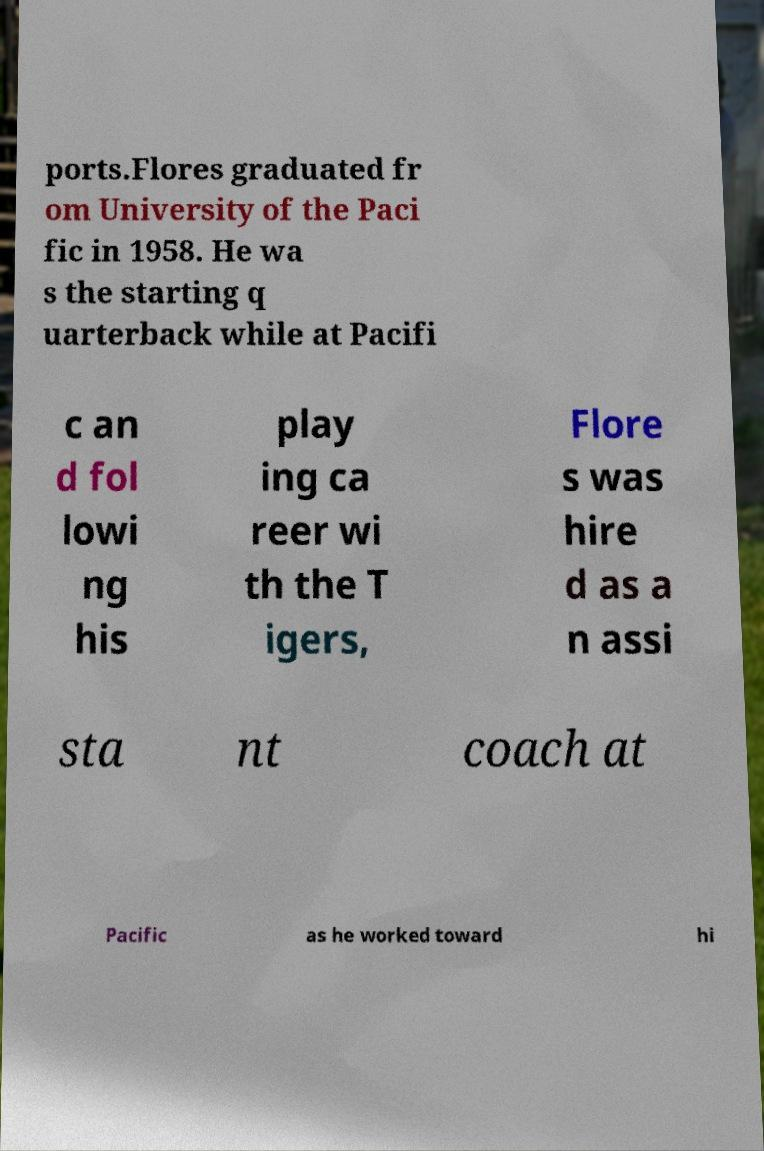Can you accurately transcribe the text from the provided image for me? ports.Flores graduated fr om University of the Paci fic in 1958. He wa s the starting q uarterback while at Pacifi c an d fol lowi ng his play ing ca reer wi th the T igers, Flore s was hire d as a n assi sta nt coach at Pacific as he worked toward hi 